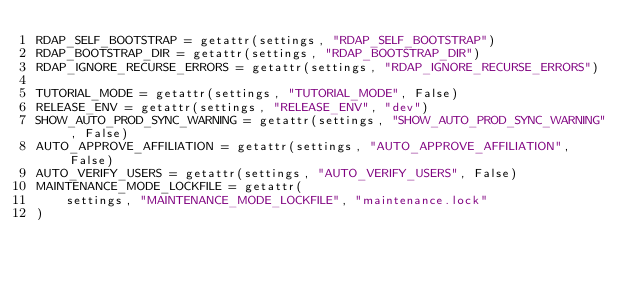Convert code to text. <code><loc_0><loc_0><loc_500><loc_500><_Python_>RDAP_SELF_BOOTSTRAP = getattr(settings, "RDAP_SELF_BOOTSTRAP")
RDAP_BOOTSTRAP_DIR = getattr(settings, "RDAP_BOOTSTRAP_DIR")
RDAP_IGNORE_RECURSE_ERRORS = getattr(settings, "RDAP_IGNORE_RECURSE_ERRORS")

TUTORIAL_MODE = getattr(settings, "TUTORIAL_MODE", False)
RELEASE_ENV = getattr(settings, "RELEASE_ENV", "dev")
SHOW_AUTO_PROD_SYNC_WARNING = getattr(settings, "SHOW_AUTO_PROD_SYNC_WARNING", False)
AUTO_APPROVE_AFFILIATION = getattr(settings, "AUTO_APPROVE_AFFILIATION", False)
AUTO_VERIFY_USERS = getattr(settings, "AUTO_VERIFY_USERS", False)
MAINTENANCE_MODE_LOCKFILE = getattr(
    settings, "MAINTENANCE_MODE_LOCKFILE", "maintenance.lock"
)
</code> 